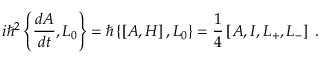<formula> <loc_0><loc_0><loc_500><loc_500>i \hbar { ^ } { 2 } \left \{ \frac { d A } { d t } , L _ { 0 } \right \} = \hbar { \left } \{ \left [ A , H \right ] , L _ { 0 } \right \} = \frac { 1 } { 4 } \left [ A , I , L _ { + } , L _ { - } \right ] \, .</formula> 